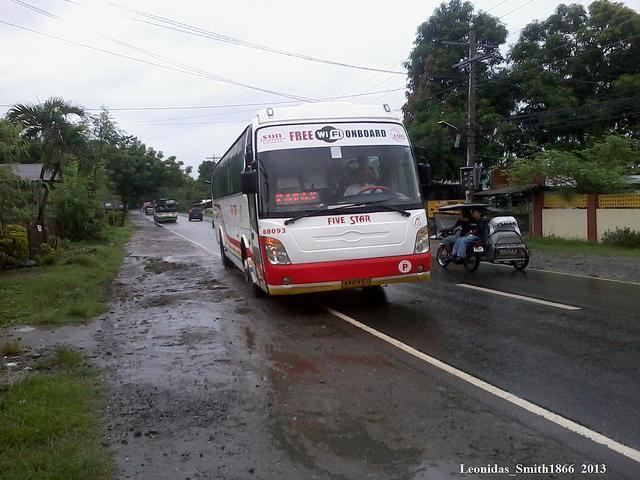How many cars in the shot?
Give a very brief answer. 2. How many cars are in the photo?
Give a very brief answer. 1. 